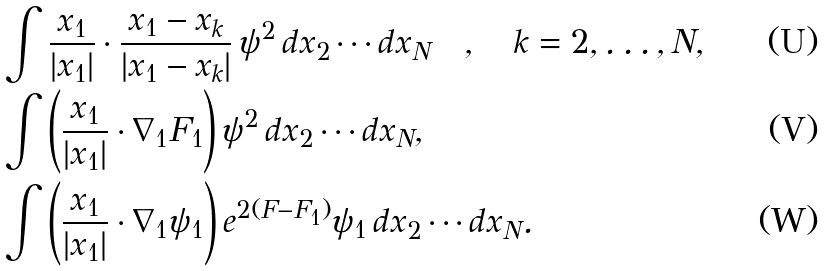<formula> <loc_0><loc_0><loc_500><loc_500>& \int \frac { x _ { 1 } } { | x _ { 1 } | } \cdot \frac { x _ { 1 } - x _ { k } } { | x _ { 1 } - x _ { k } | } \, \psi ^ { 2 } \, d x _ { 2 } \cdots d x _ { N } \quad , \quad k = 2 , \dots , N , \\ & \int \left ( \frac { x _ { 1 } } { | x _ { 1 } | } \cdot \nabla _ { 1 } F _ { 1 } \right ) \psi ^ { 2 } \, d x _ { 2 } \cdots d x _ { N } , \\ & \int \left ( \frac { x _ { 1 } } { | x _ { 1 } | } \cdot \nabla _ { 1 } \psi _ { 1 } \right ) e ^ { 2 ( F - F _ { 1 } ) } \psi _ { 1 } \, d x _ { 2 } \cdots d x _ { N } .</formula> 